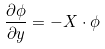<formula> <loc_0><loc_0><loc_500><loc_500>\frac { \partial \phi } { \partial y } = - X \cdot \phi</formula> 